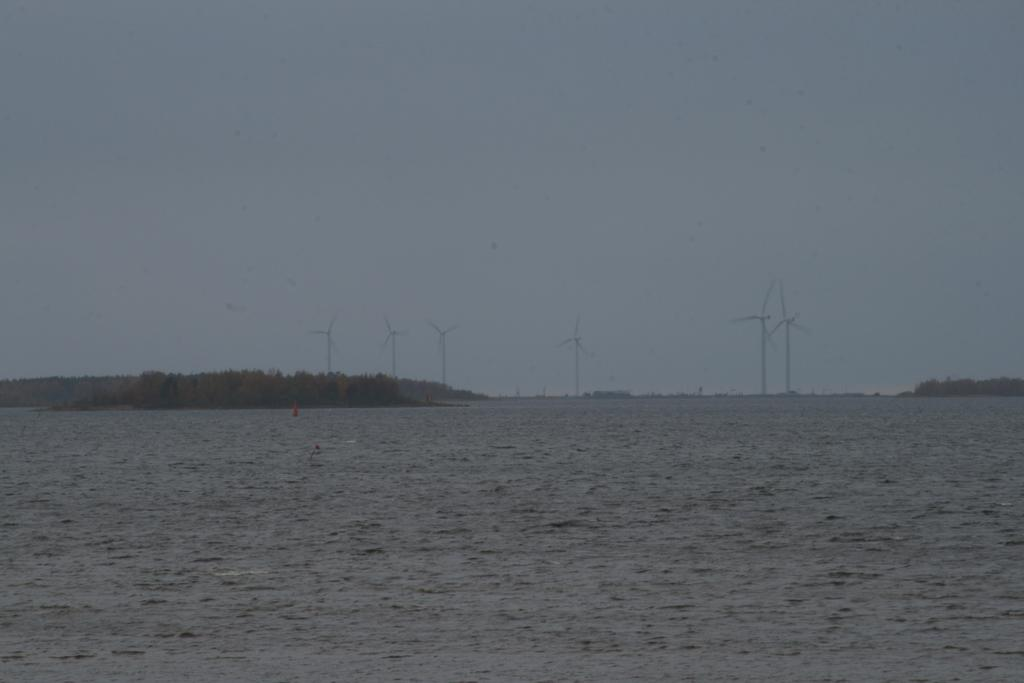What is the primary element present in the image? There is water in the image. What structures can be seen in the image? There are windmills in the image. What type of vegetation is present in the image? There are trees in the image. What can be seen in the background of the image? The sky is visible in the background of the image. What type of pie is being served on the table in the image? There is no table or pie present in the image; it features water, windmills, trees, and the sky. 